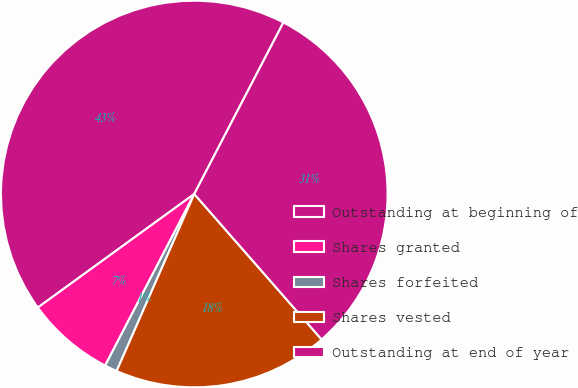<chart> <loc_0><loc_0><loc_500><loc_500><pie_chart><fcel>Outstanding at beginning of<fcel>Shares granted<fcel>Shares forfeited<fcel>Shares vested<fcel>Outstanding at end of year<nl><fcel>42.62%<fcel>7.38%<fcel>1.05%<fcel>18.02%<fcel>30.93%<nl></chart> 